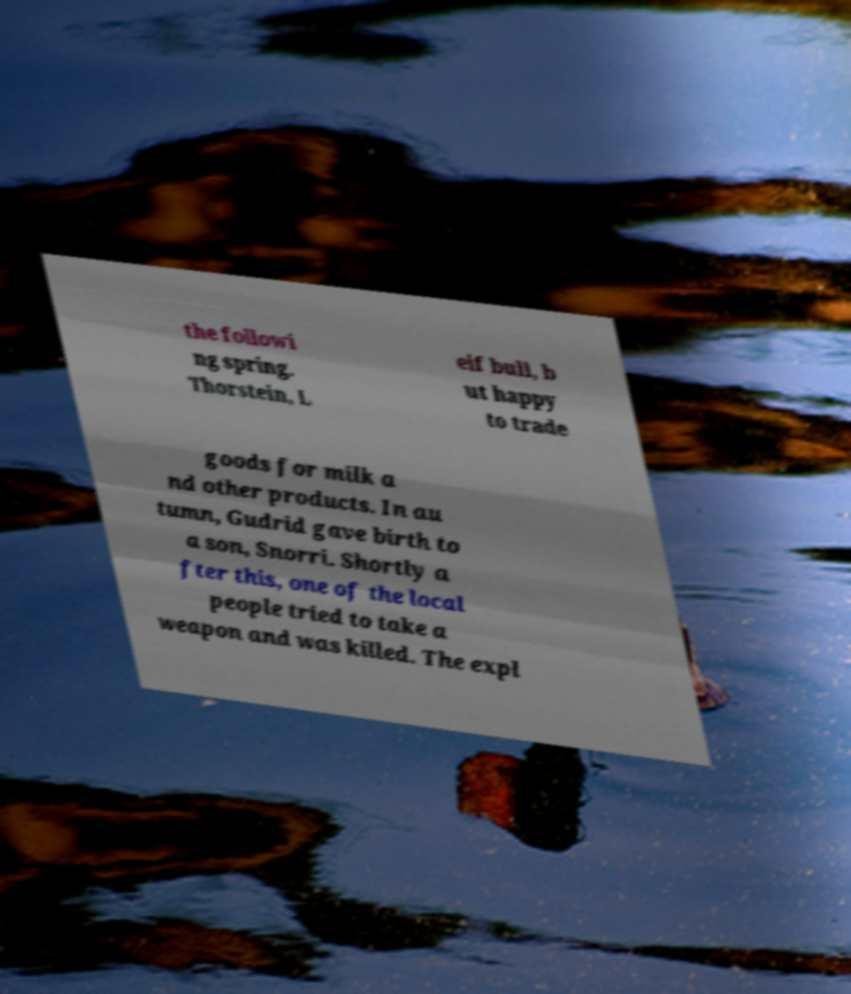I need the written content from this picture converted into text. Can you do that? the followi ng spring. Thorstein, L eif bull, b ut happy to trade goods for milk a nd other products. In au tumn, Gudrid gave birth to a son, Snorri. Shortly a fter this, one of the local people tried to take a weapon and was killed. The expl 